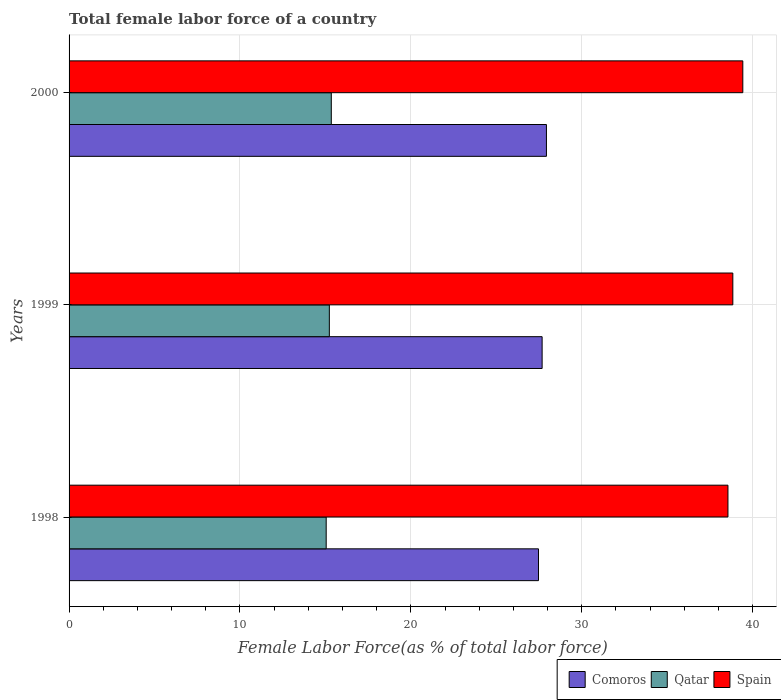How many different coloured bars are there?
Your response must be concise. 3. Are the number of bars per tick equal to the number of legend labels?
Your response must be concise. Yes. What is the label of the 2nd group of bars from the top?
Provide a short and direct response. 1999. What is the percentage of female labor force in Comoros in 2000?
Give a very brief answer. 27.93. Across all years, what is the maximum percentage of female labor force in Comoros?
Your answer should be compact. 27.93. Across all years, what is the minimum percentage of female labor force in Spain?
Offer a very short reply. 38.55. In which year was the percentage of female labor force in Comoros minimum?
Offer a very short reply. 1998. What is the total percentage of female labor force in Comoros in the graph?
Your answer should be very brief. 83.07. What is the difference between the percentage of female labor force in Qatar in 1998 and that in 2000?
Make the answer very short. -0.3. What is the difference between the percentage of female labor force in Qatar in 2000 and the percentage of female labor force in Comoros in 1998?
Your answer should be compact. -12.12. What is the average percentage of female labor force in Comoros per year?
Provide a short and direct response. 27.69. In the year 1998, what is the difference between the percentage of female labor force in Qatar and percentage of female labor force in Comoros?
Your answer should be compact. -12.42. What is the ratio of the percentage of female labor force in Qatar in 1999 to that in 2000?
Your response must be concise. 0.99. Is the percentage of female labor force in Qatar in 1998 less than that in 2000?
Provide a succinct answer. Yes. What is the difference between the highest and the second highest percentage of female labor force in Spain?
Give a very brief answer. 0.58. What is the difference between the highest and the lowest percentage of female labor force in Comoros?
Provide a short and direct response. 0.47. Is the sum of the percentage of female labor force in Qatar in 1999 and 2000 greater than the maximum percentage of female labor force in Spain across all years?
Ensure brevity in your answer.  No. What does the 2nd bar from the bottom in 2000 represents?
Offer a terse response. Qatar. Is it the case that in every year, the sum of the percentage of female labor force in Spain and percentage of female labor force in Comoros is greater than the percentage of female labor force in Qatar?
Ensure brevity in your answer.  Yes. How many years are there in the graph?
Offer a very short reply. 3. What is the title of the graph?
Your answer should be compact. Total female labor force of a country. Does "Burkina Faso" appear as one of the legend labels in the graph?
Your answer should be compact. No. What is the label or title of the X-axis?
Your answer should be very brief. Female Labor Force(as % of total labor force). What is the label or title of the Y-axis?
Your answer should be compact. Years. What is the Female Labor Force(as % of total labor force) in Comoros in 1998?
Offer a terse response. 27.47. What is the Female Labor Force(as % of total labor force) of Qatar in 1998?
Provide a succinct answer. 15.04. What is the Female Labor Force(as % of total labor force) in Spain in 1998?
Provide a succinct answer. 38.55. What is the Female Labor Force(as % of total labor force) in Comoros in 1999?
Provide a short and direct response. 27.68. What is the Female Labor Force(as % of total labor force) of Qatar in 1999?
Give a very brief answer. 15.23. What is the Female Labor Force(as % of total labor force) in Spain in 1999?
Offer a very short reply. 38.84. What is the Female Labor Force(as % of total labor force) in Comoros in 2000?
Make the answer very short. 27.93. What is the Female Labor Force(as % of total labor force) in Qatar in 2000?
Provide a short and direct response. 15.34. What is the Female Labor Force(as % of total labor force) of Spain in 2000?
Your answer should be very brief. 39.42. Across all years, what is the maximum Female Labor Force(as % of total labor force) of Comoros?
Your answer should be compact. 27.93. Across all years, what is the maximum Female Labor Force(as % of total labor force) in Qatar?
Your answer should be compact. 15.34. Across all years, what is the maximum Female Labor Force(as % of total labor force) in Spain?
Ensure brevity in your answer.  39.42. Across all years, what is the minimum Female Labor Force(as % of total labor force) in Comoros?
Your response must be concise. 27.47. Across all years, what is the minimum Female Labor Force(as % of total labor force) of Qatar?
Your response must be concise. 15.04. Across all years, what is the minimum Female Labor Force(as % of total labor force) in Spain?
Make the answer very short. 38.55. What is the total Female Labor Force(as % of total labor force) of Comoros in the graph?
Your response must be concise. 83.07. What is the total Female Labor Force(as % of total labor force) of Qatar in the graph?
Give a very brief answer. 45.62. What is the total Female Labor Force(as % of total labor force) in Spain in the graph?
Give a very brief answer. 116.81. What is the difference between the Female Labor Force(as % of total labor force) of Comoros in 1998 and that in 1999?
Ensure brevity in your answer.  -0.21. What is the difference between the Female Labor Force(as % of total labor force) in Qatar in 1998 and that in 1999?
Give a very brief answer. -0.18. What is the difference between the Female Labor Force(as % of total labor force) of Spain in 1998 and that in 1999?
Provide a succinct answer. -0.29. What is the difference between the Female Labor Force(as % of total labor force) of Comoros in 1998 and that in 2000?
Give a very brief answer. -0.47. What is the difference between the Female Labor Force(as % of total labor force) in Qatar in 1998 and that in 2000?
Make the answer very short. -0.3. What is the difference between the Female Labor Force(as % of total labor force) in Spain in 1998 and that in 2000?
Your answer should be compact. -0.87. What is the difference between the Female Labor Force(as % of total labor force) of Comoros in 1999 and that in 2000?
Give a very brief answer. -0.25. What is the difference between the Female Labor Force(as % of total labor force) in Qatar in 1999 and that in 2000?
Your response must be concise. -0.12. What is the difference between the Female Labor Force(as % of total labor force) in Spain in 1999 and that in 2000?
Your answer should be very brief. -0.58. What is the difference between the Female Labor Force(as % of total labor force) of Comoros in 1998 and the Female Labor Force(as % of total labor force) of Qatar in 1999?
Provide a short and direct response. 12.24. What is the difference between the Female Labor Force(as % of total labor force) in Comoros in 1998 and the Female Labor Force(as % of total labor force) in Spain in 1999?
Your response must be concise. -11.37. What is the difference between the Female Labor Force(as % of total labor force) of Qatar in 1998 and the Female Labor Force(as % of total labor force) of Spain in 1999?
Your answer should be compact. -23.79. What is the difference between the Female Labor Force(as % of total labor force) of Comoros in 1998 and the Female Labor Force(as % of total labor force) of Qatar in 2000?
Your answer should be compact. 12.12. What is the difference between the Female Labor Force(as % of total labor force) in Comoros in 1998 and the Female Labor Force(as % of total labor force) in Spain in 2000?
Your answer should be very brief. -11.95. What is the difference between the Female Labor Force(as % of total labor force) of Qatar in 1998 and the Female Labor Force(as % of total labor force) of Spain in 2000?
Keep it short and to the point. -24.38. What is the difference between the Female Labor Force(as % of total labor force) of Comoros in 1999 and the Female Labor Force(as % of total labor force) of Qatar in 2000?
Give a very brief answer. 12.34. What is the difference between the Female Labor Force(as % of total labor force) in Comoros in 1999 and the Female Labor Force(as % of total labor force) in Spain in 2000?
Keep it short and to the point. -11.74. What is the difference between the Female Labor Force(as % of total labor force) of Qatar in 1999 and the Female Labor Force(as % of total labor force) of Spain in 2000?
Ensure brevity in your answer.  -24.19. What is the average Female Labor Force(as % of total labor force) in Comoros per year?
Your answer should be very brief. 27.69. What is the average Female Labor Force(as % of total labor force) in Qatar per year?
Offer a very short reply. 15.21. What is the average Female Labor Force(as % of total labor force) of Spain per year?
Make the answer very short. 38.94. In the year 1998, what is the difference between the Female Labor Force(as % of total labor force) in Comoros and Female Labor Force(as % of total labor force) in Qatar?
Give a very brief answer. 12.42. In the year 1998, what is the difference between the Female Labor Force(as % of total labor force) in Comoros and Female Labor Force(as % of total labor force) in Spain?
Offer a very short reply. -11.09. In the year 1998, what is the difference between the Female Labor Force(as % of total labor force) in Qatar and Female Labor Force(as % of total labor force) in Spain?
Offer a very short reply. -23.51. In the year 1999, what is the difference between the Female Labor Force(as % of total labor force) of Comoros and Female Labor Force(as % of total labor force) of Qatar?
Provide a succinct answer. 12.45. In the year 1999, what is the difference between the Female Labor Force(as % of total labor force) of Comoros and Female Labor Force(as % of total labor force) of Spain?
Your response must be concise. -11.16. In the year 1999, what is the difference between the Female Labor Force(as % of total labor force) in Qatar and Female Labor Force(as % of total labor force) in Spain?
Your answer should be compact. -23.61. In the year 2000, what is the difference between the Female Labor Force(as % of total labor force) in Comoros and Female Labor Force(as % of total labor force) in Qatar?
Ensure brevity in your answer.  12.59. In the year 2000, what is the difference between the Female Labor Force(as % of total labor force) of Comoros and Female Labor Force(as % of total labor force) of Spain?
Your answer should be very brief. -11.49. In the year 2000, what is the difference between the Female Labor Force(as % of total labor force) in Qatar and Female Labor Force(as % of total labor force) in Spain?
Ensure brevity in your answer.  -24.08. What is the ratio of the Female Labor Force(as % of total labor force) of Qatar in 1998 to that in 1999?
Your response must be concise. 0.99. What is the ratio of the Female Labor Force(as % of total labor force) of Comoros in 1998 to that in 2000?
Give a very brief answer. 0.98. What is the ratio of the Female Labor Force(as % of total labor force) of Qatar in 1998 to that in 2000?
Offer a terse response. 0.98. What is the ratio of the Female Labor Force(as % of total labor force) of Spain in 1998 to that in 2000?
Your response must be concise. 0.98. What is the ratio of the Female Labor Force(as % of total labor force) in Comoros in 1999 to that in 2000?
Provide a short and direct response. 0.99. What is the ratio of the Female Labor Force(as % of total labor force) in Spain in 1999 to that in 2000?
Offer a very short reply. 0.99. What is the difference between the highest and the second highest Female Labor Force(as % of total labor force) of Comoros?
Provide a short and direct response. 0.25. What is the difference between the highest and the second highest Female Labor Force(as % of total labor force) in Qatar?
Keep it short and to the point. 0.12. What is the difference between the highest and the second highest Female Labor Force(as % of total labor force) of Spain?
Make the answer very short. 0.58. What is the difference between the highest and the lowest Female Labor Force(as % of total labor force) in Comoros?
Keep it short and to the point. 0.47. What is the difference between the highest and the lowest Female Labor Force(as % of total labor force) in Qatar?
Your response must be concise. 0.3. What is the difference between the highest and the lowest Female Labor Force(as % of total labor force) of Spain?
Make the answer very short. 0.87. 